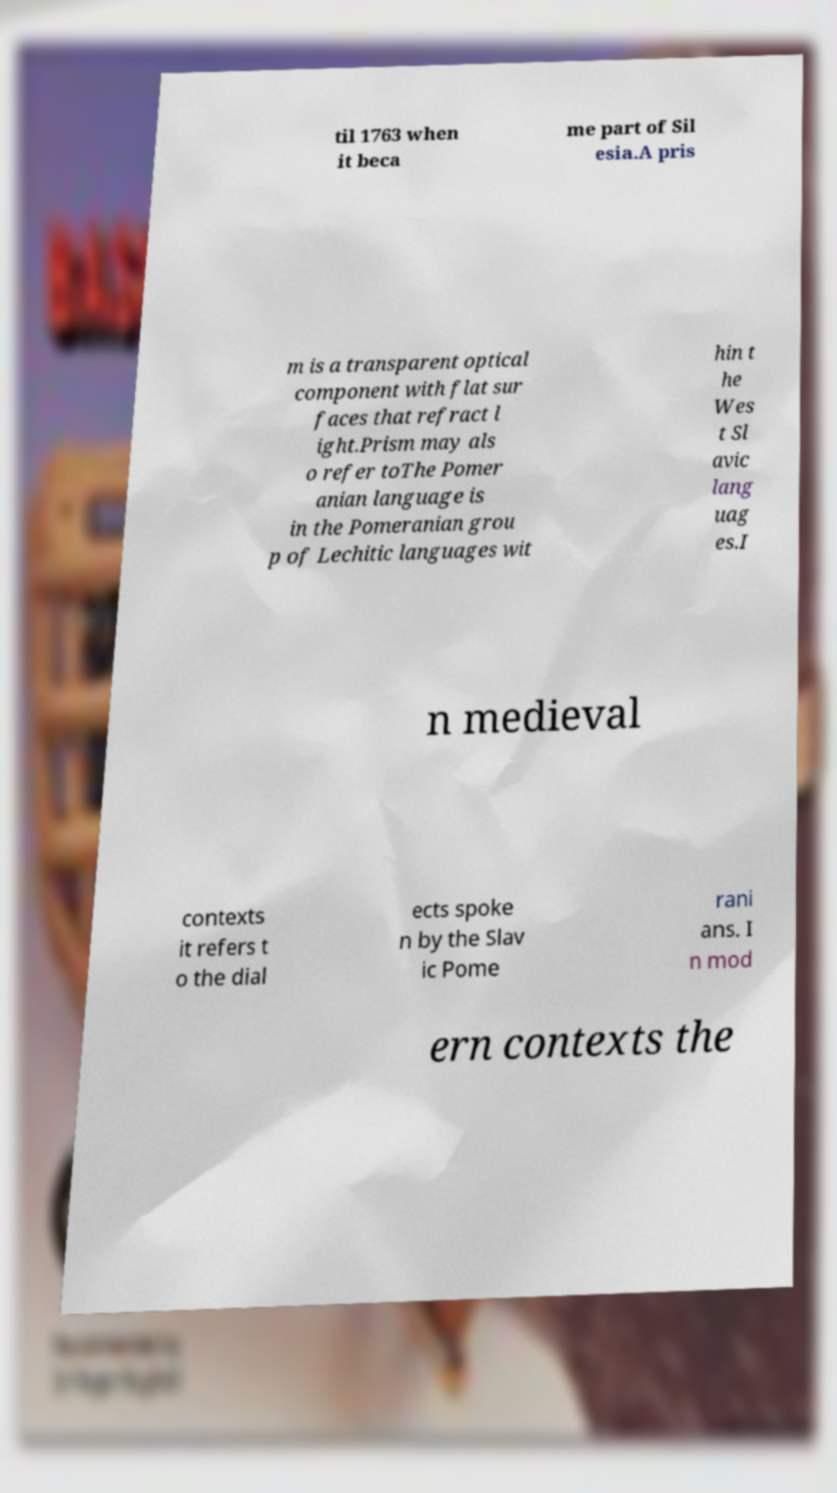What messages or text are displayed in this image? I need them in a readable, typed format. til 1763 when it beca me part of Sil esia.A pris m is a transparent optical component with flat sur faces that refract l ight.Prism may als o refer toThe Pomer anian language is in the Pomeranian grou p of Lechitic languages wit hin t he Wes t Sl avic lang uag es.I n medieval contexts it refers t o the dial ects spoke n by the Slav ic Pome rani ans. I n mod ern contexts the 